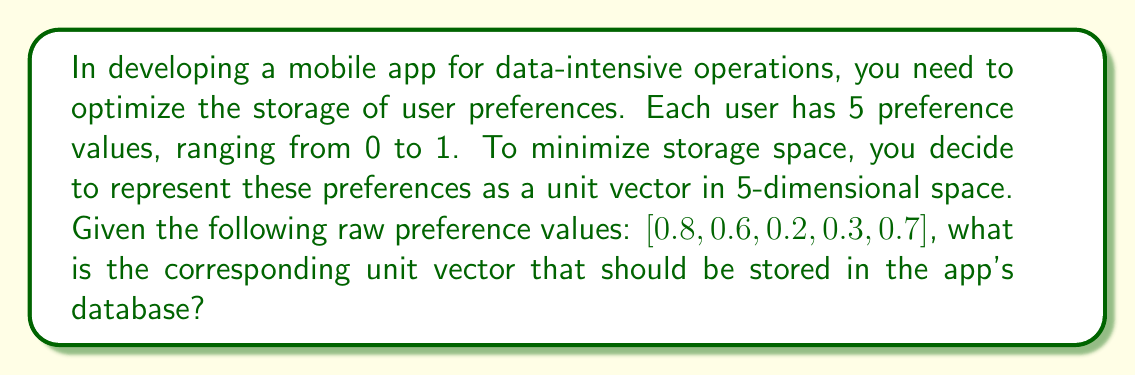Can you solve this math problem? To solve this problem, we need to follow these steps:

1. Understand the concept of a unit vector:
   A unit vector is a vector with a magnitude (length) of 1.

2. Calculate the magnitude of the given vector:
   Let's call our vector $\mathbf{v} = [0.8, 0.6, 0.2, 0.3, 0.7]$
   The magnitude is given by the square root of the sum of squared components:
   
   $$\|\mathbf{v}\| = \sqrt{0.8^2 + 0.6^2 + 0.2^2 + 0.3^2 + 0.7^2}$$
   $$\|\mathbf{v}\| = \sqrt{0.64 + 0.36 + 0.04 + 0.09 + 0.49}$$
   $$\|\mathbf{v}\| = \sqrt{1.62} \approx 1.2728$$

3. Normalize the vector:
   To get the unit vector $\mathbf{u}$, we divide each component of $\mathbf{v}$ by its magnitude:
   
   $$\mathbf{u} = \frac{\mathbf{v}}{\|\mathbf{v}\|} = \left[\frac{0.8}{1.2728}, \frac{0.6}{1.2728}, \frac{0.2}{1.2728}, \frac{0.3}{1.2728}, \frac{0.7}{1.2728}\right]$$

4. Calculate the components of the unit vector:
   $$\mathbf{u} \approx [0.6286, 0.4715, 0.1572, 0.2357, 0.5500]$$

5. Verify that it's a unit vector:
   We can check that the magnitude of $\mathbf{u}$ is indeed 1:
   $$\|\mathbf{u}\| = \sqrt{0.6286^2 + 0.4715^2 + 0.1572^2 + 0.2357^2 + 0.5500^2} \approx 1$$
Answer: The optimal unit vector for storing the user preferences is approximately:
$$\mathbf{u} \approx [0.6286, 0.4715, 0.1572, 0.2357, 0.5500]$$ 